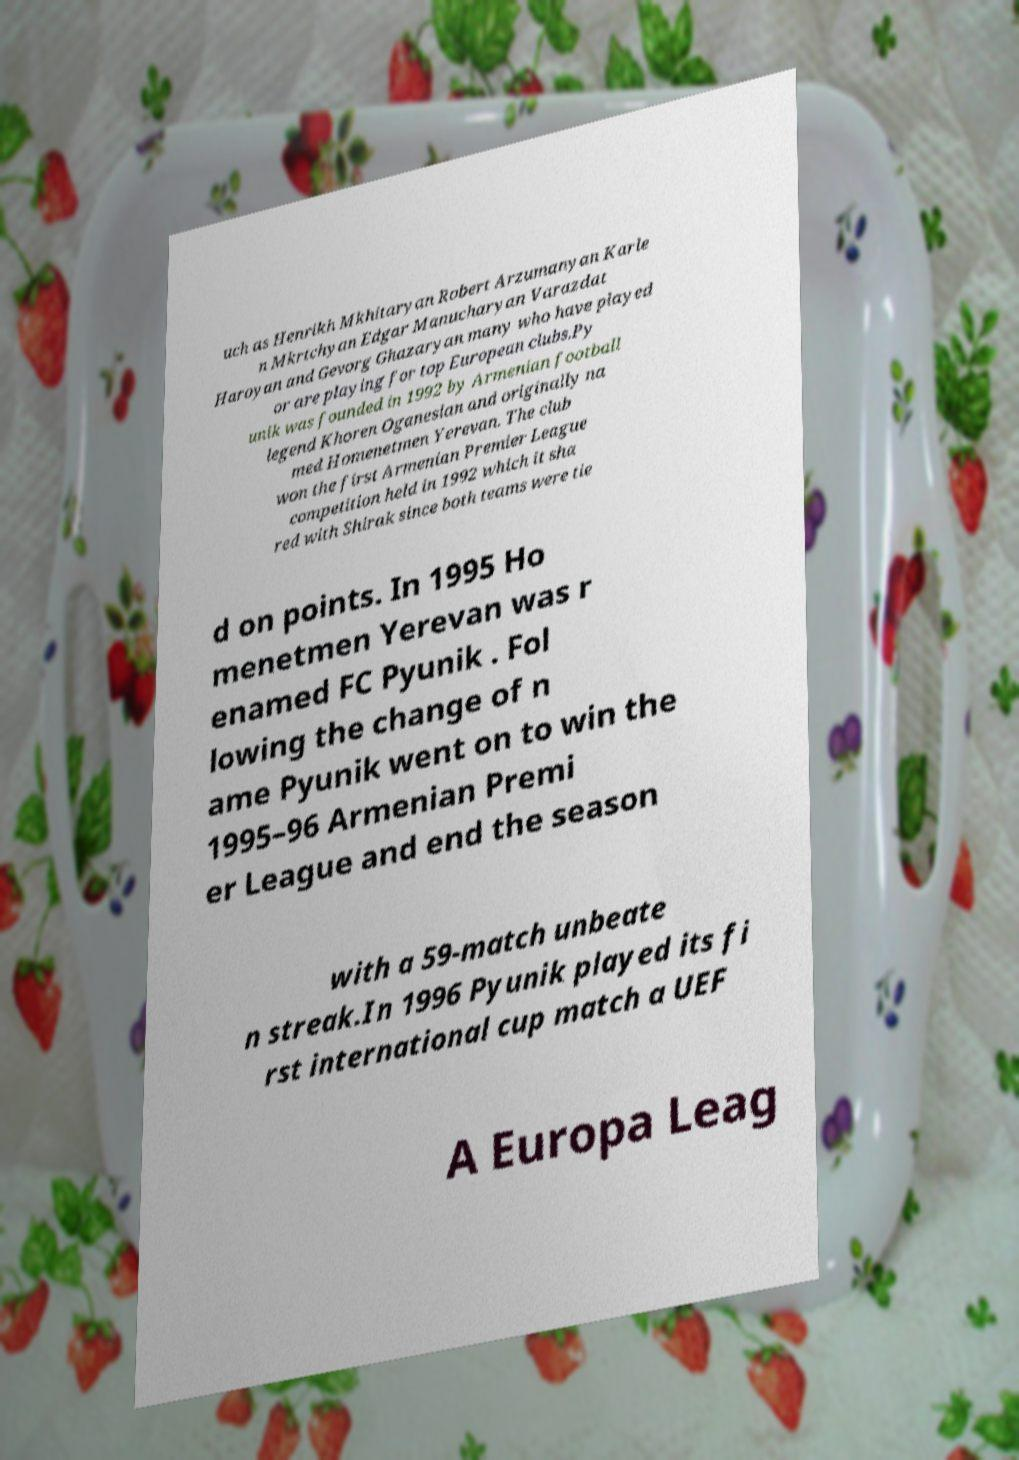Please read and relay the text visible in this image. What does it say? uch as Henrikh Mkhitaryan Robert Arzumanyan Karle n Mkrtchyan Edgar Manucharyan Varazdat Haroyan and Gevorg Ghazaryan many who have played or are playing for top European clubs.Py unik was founded in 1992 by Armenian football legend Khoren Oganesian and originally na med Homenetmen Yerevan. The club won the first Armenian Premier League competition held in 1992 which it sha red with Shirak since both teams were tie d on points. In 1995 Ho menetmen Yerevan was r enamed FC Pyunik . Fol lowing the change of n ame Pyunik went on to win the 1995–96 Armenian Premi er League and end the season with a 59-match unbeate n streak.In 1996 Pyunik played its fi rst international cup match a UEF A Europa Leag 